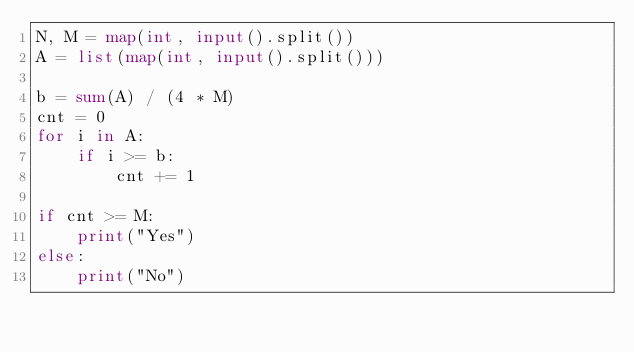Convert code to text. <code><loc_0><loc_0><loc_500><loc_500><_Python_>N, M = map(int, input().split())
A = list(map(int, input().split()))

b = sum(A) / (4 * M)
cnt = 0
for i in A:
	if i >= b:
		cnt += 1

if cnt >= M:
	print("Yes")
else:
	print("No")</code> 